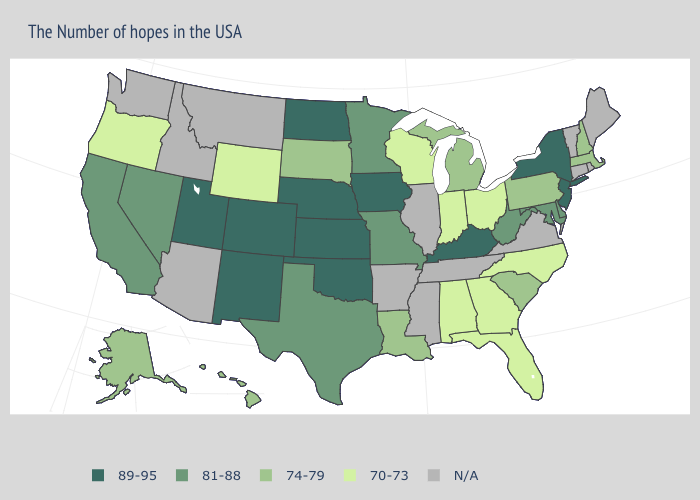Among the states that border Alabama , which have the lowest value?
Write a very short answer. Florida, Georgia. Does Indiana have the lowest value in the USA?
Be succinct. Yes. Name the states that have a value in the range 74-79?
Quick response, please. Massachusetts, New Hampshire, Pennsylvania, South Carolina, Michigan, Louisiana, South Dakota, Alaska, Hawaii. Name the states that have a value in the range 81-88?
Concise answer only. Delaware, Maryland, West Virginia, Missouri, Minnesota, Texas, Nevada, California. What is the value of Tennessee?
Concise answer only. N/A. Does Iowa have the lowest value in the MidWest?
Keep it brief. No. Which states have the lowest value in the USA?
Concise answer only. North Carolina, Ohio, Florida, Georgia, Indiana, Alabama, Wisconsin, Wyoming, Oregon. What is the value of Hawaii?
Concise answer only. 74-79. Among the states that border Minnesota , does Wisconsin have the lowest value?
Short answer required. Yes. Does Utah have the highest value in the West?
Keep it brief. Yes. Does Nebraska have the highest value in the MidWest?
Short answer required. Yes. Is the legend a continuous bar?
Concise answer only. No. 